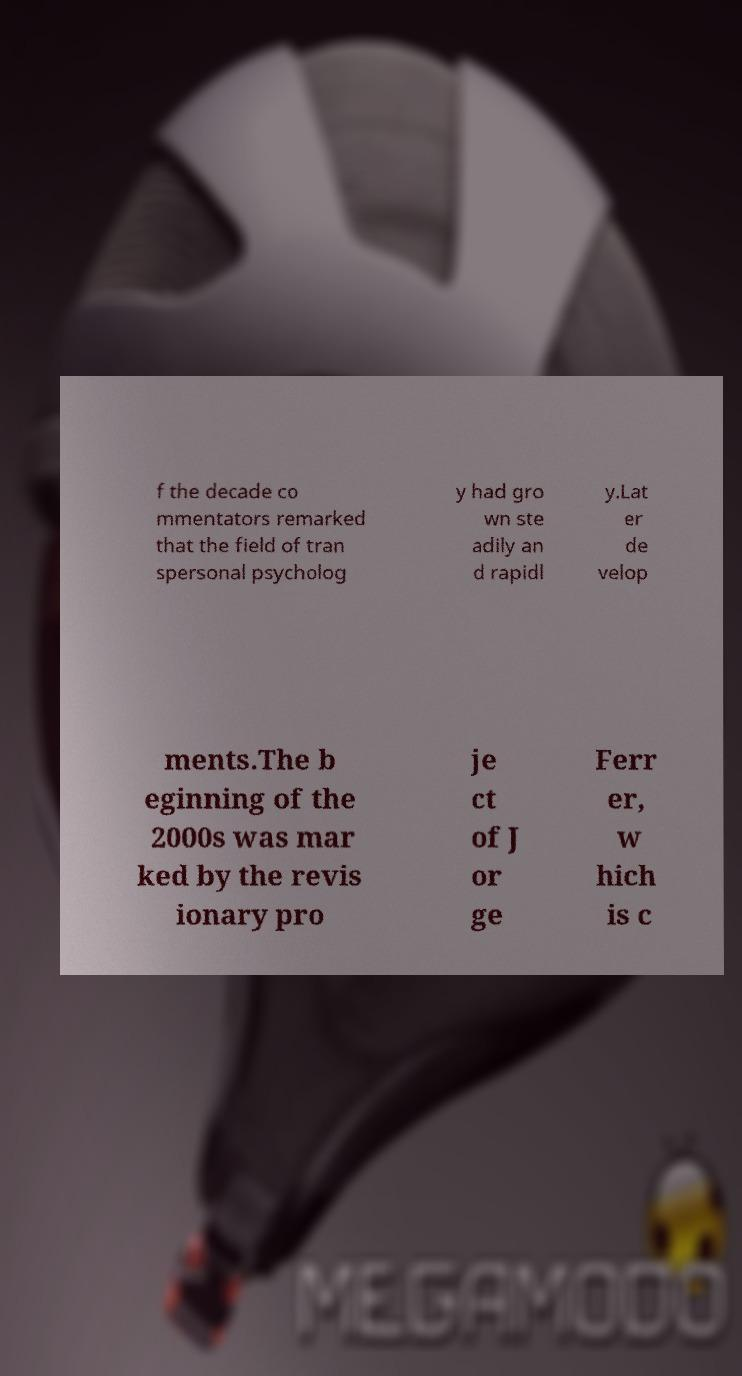What messages or text are displayed in this image? I need them in a readable, typed format. f the decade co mmentators remarked that the field of tran spersonal psycholog y had gro wn ste adily an d rapidl y.Lat er de velop ments.The b eginning of the 2000s was mar ked by the revis ionary pro je ct of J or ge Ferr er, w hich is c 